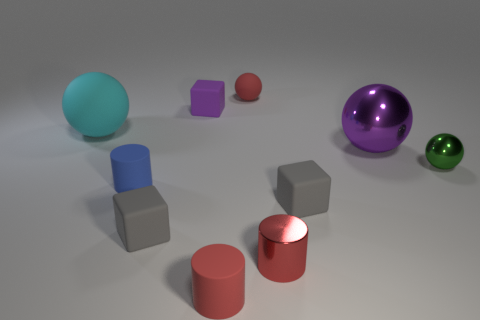Are there fewer large brown objects than green objects? Yes, there are fewer large brown objects than green ones. In the image, we can see only one large brown object, while there are two green objects present; one of them is smaller and the other one is larger, situated towards the right. 